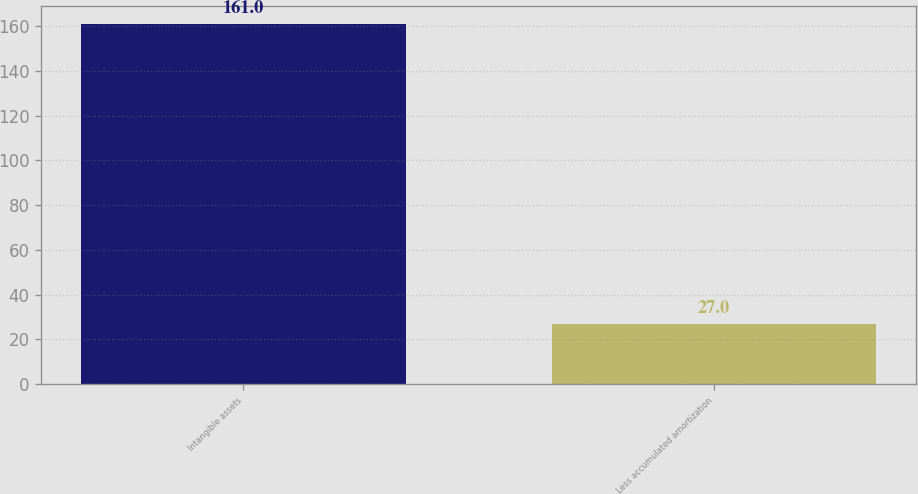Convert chart to OTSL. <chart><loc_0><loc_0><loc_500><loc_500><bar_chart><fcel>Intangible assets<fcel>Less accumulated amortization<nl><fcel>161<fcel>27<nl></chart> 